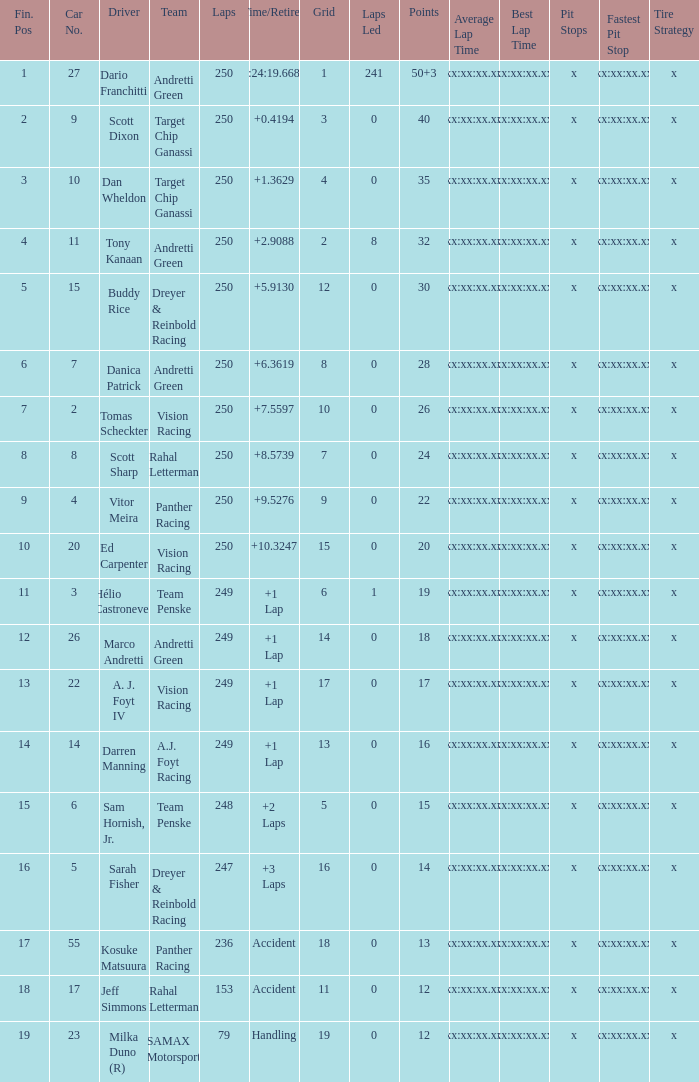Name the total number of cars for panther racing and grid of 9 1.0. Parse the full table. {'header': ['Fin. Pos', 'Car No.', 'Driver', 'Team', 'Laps', 'Time/Retired', 'Grid', 'Laps Led', 'Points', 'Average Lap Time', 'Best Lap Time', 'Pit Stops', 'Fastest Pit Stop', 'Tire Strategy'], 'rows': [['1', '27', 'Dario Franchitti', 'Andretti Green', '250', '1:24:19.6684', '1', '241', '50+3', 'xx:xx:xx.xx', 'xx:xx:xx.xx', 'x', 'xx:xx:xx.xx', 'x'], ['2', '9', 'Scott Dixon', 'Target Chip Ganassi', '250', '+0.4194', '3', '0', '40', 'xx:xx:xx.xx', 'xx:xx:xx.xx', 'x', 'xx:xx:xx.xx', 'x'], ['3', '10', 'Dan Wheldon', 'Target Chip Ganassi', '250', '+1.3629', '4', '0', '35', 'xx:xx:xx.xx', 'xx:xx:xx.xx', 'x', 'xx:xx:xx.xx', 'x'], ['4', '11', 'Tony Kanaan', 'Andretti Green', '250', '+2.9088', '2', '8', '32', 'xx:xx:xx.xx', 'xx:xx:xx.xx', 'x', 'xx:xx:xx.xx', 'x'], ['5', '15', 'Buddy Rice', 'Dreyer & Reinbold Racing', '250', '+5.9130', '12', '0', '30', 'xx:xx:xx.xx', 'xx:xx:xx.xx', 'x', 'xx:xx:xx.xx', 'x'], ['6', '7', 'Danica Patrick', 'Andretti Green', '250', '+6.3619', '8', '0', '28', 'xx:xx:xx.xx', 'xx:xx:xx.xx', 'x', 'xx:xx:xx.xx', 'x'], ['7', '2', 'Tomas Scheckter', 'Vision Racing', '250', '+7.5597', '10', '0', '26', 'xx:xx:xx.xx', 'xx:xx:xx.xx', 'x', 'xx:xx:xx.xx', 'x'], ['8', '8', 'Scott Sharp', 'Rahal Letterman', '250', '+8.5739', '7', '0', '24', 'xx:xx:xx.xx', 'xx:xx:xx.xx', 'x', 'xx:xx:xx.xx', 'x'], ['9', '4', 'Vitor Meira', 'Panther Racing', '250', '+9.5276', '9', '0', '22', 'xx:xx:xx.xx', 'xx:xx:xx.xx', 'x', 'xx:xx:xx.xx', 'x'], ['10', '20', 'Ed Carpenter', 'Vision Racing', '250', '+10.3247', '15', '0', '20', 'xx:xx:xx.xx', 'xx:xx:xx.xx', 'x', 'xx:xx:xx.xx', 'x'], ['11', '3', 'Hélio Castroneves', 'Team Penske', '249', '+1 Lap', '6', '1', '19', 'xx:xx:xx.xx', 'xx:xx:xx.xx', 'x', 'xx:xx:xx.xx', 'x'], ['12', '26', 'Marco Andretti', 'Andretti Green', '249', '+1 Lap', '14', '0', '18', 'xx:xx:xx.xx', 'xx:xx:xx.xx', 'x', 'xx:xx:xx.xx', 'x'], ['13', '22', 'A. J. Foyt IV', 'Vision Racing', '249', '+1 Lap', '17', '0', '17', 'xx:xx:xx.xx', 'xx:xx:xx.xx', 'x', 'xx:xx:xx.xx', 'x'], ['14', '14', 'Darren Manning', 'A.J. Foyt Racing', '249', '+1 Lap', '13', '0', '16', 'xx:xx:xx.xx', 'xx:xx:xx.xx', 'x', 'xx:xx:xx.xx', 'x'], ['15', '6', 'Sam Hornish, Jr.', 'Team Penske', '248', '+2 Laps', '5', '0', '15', 'xx:xx:xx.xx', 'xx:xx:xx.xx', 'x', 'xx:xx:xx.xx', 'x'], ['16', '5', 'Sarah Fisher', 'Dreyer & Reinbold Racing', '247', '+3 Laps', '16', '0', '14', 'xx:xx:xx.xx', 'xx:xx:xx.xx', 'x', 'xx:xx:xx.xx', 'x'], ['17', '55', 'Kosuke Matsuura', 'Panther Racing', '236', 'Accident', '18', '0', '13', 'xx:xx:xx.xx', 'xx:xx:xx.xx', 'x', 'xx:xx:xx.xx', 'x'], ['18', '17', 'Jeff Simmons', 'Rahal Letterman', '153', 'Accident', '11', '0', '12', 'xx:xx:xx.xx', 'xx:xx:xx.xx', 'x', 'xx:xx:xx.xx', 'x'], ['19', '23', 'Milka Duno (R)', 'SAMAX Motorsport', '79', 'Handling', '19', '0', '12', 'xx:xx:xx.xx', 'xx:xx:xx.xx', 'x', 'xx:xx:xx.xx', 'x']]} 